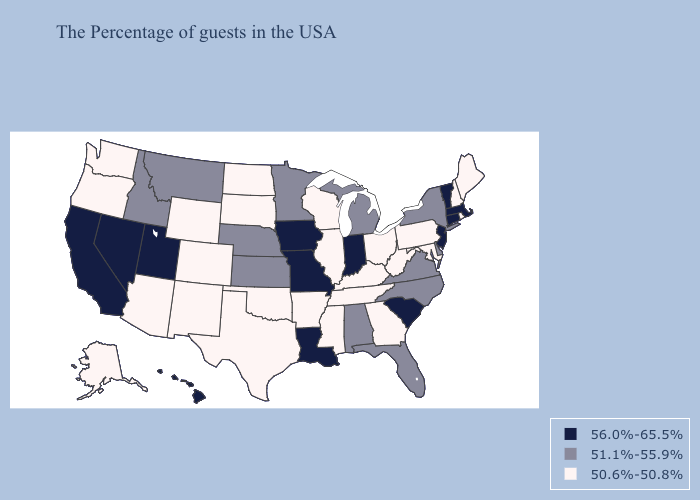Name the states that have a value in the range 50.6%-50.8%?
Write a very short answer. Maine, Rhode Island, New Hampshire, Maryland, Pennsylvania, West Virginia, Ohio, Georgia, Kentucky, Tennessee, Wisconsin, Illinois, Mississippi, Arkansas, Oklahoma, Texas, South Dakota, North Dakota, Wyoming, Colorado, New Mexico, Arizona, Washington, Oregon, Alaska. Does Louisiana have a higher value than Utah?
Keep it brief. No. What is the value of Iowa?
Be succinct. 56.0%-65.5%. What is the value of Nebraska?
Give a very brief answer. 51.1%-55.9%. Does Connecticut have the highest value in the USA?
Write a very short answer. Yes. What is the highest value in the USA?
Be succinct. 56.0%-65.5%. Does New Mexico have a lower value than Colorado?
Answer briefly. No. What is the value of Massachusetts?
Quick response, please. 56.0%-65.5%. What is the value of Idaho?
Write a very short answer. 51.1%-55.9%. Name the states that have a value in the range 56.0%-65.5%?
Give a very brief answer. Massachusetts, Vermont, Connecticut, New Jersey, South Carolina, Indiana, Louisiana, Missouri, Iowa, Utah, Nevada, California, Hawaii. Which states have the highest value in the USA?
Short answer required. Massachusetts, Vermont, Connecticut, New Jersey, South Carolina, Indiana, Louisiana, Missouri, Iowa, Utah, Nevada, California, Hawaii. Does Michigan have a lower value than Utah?
Write a very short answer. Yes. Name the states that have a value in the range 50.6%-50.8%?
Write a very short answer. Maine, Rhode Island, New Hampshire, Maryland, Pennsylvania, West Virginia, Ohio, Georgia, Kentucky, Tennessee, Wisconsin, Illinois, Mississippi, Arkansas, Oklahoma, Texas, South Dakota, North Dakota, Wyoming, Colorado, New Mexico, Arizona, Washington, Oregon, Alaska. Name the states that have a value in the range 51.1%-55.9%?
Be succinct. New York, Delaware, Virginia, North Carolina, Florida, Michigan, Alabama, Minnesota, Kansas, Nebraska, Montana, Idaho. 